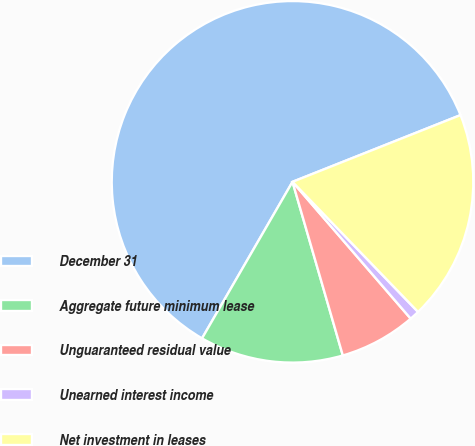Convert chart to OTSL. <chart><loc_0><loc_0><loc_500><loc_500><pie_chart><fcel>December 31<fcel>Aggregate future minimum lease<fcel>Unguaranteed residual value<fcel>Unearned interest income<fcel>Net investment in leases<nl><fcel>60.64%<fcel>12.83%<fcel>6.85%<fcel>0.88%<fcel>18.8%<nl></chart> 